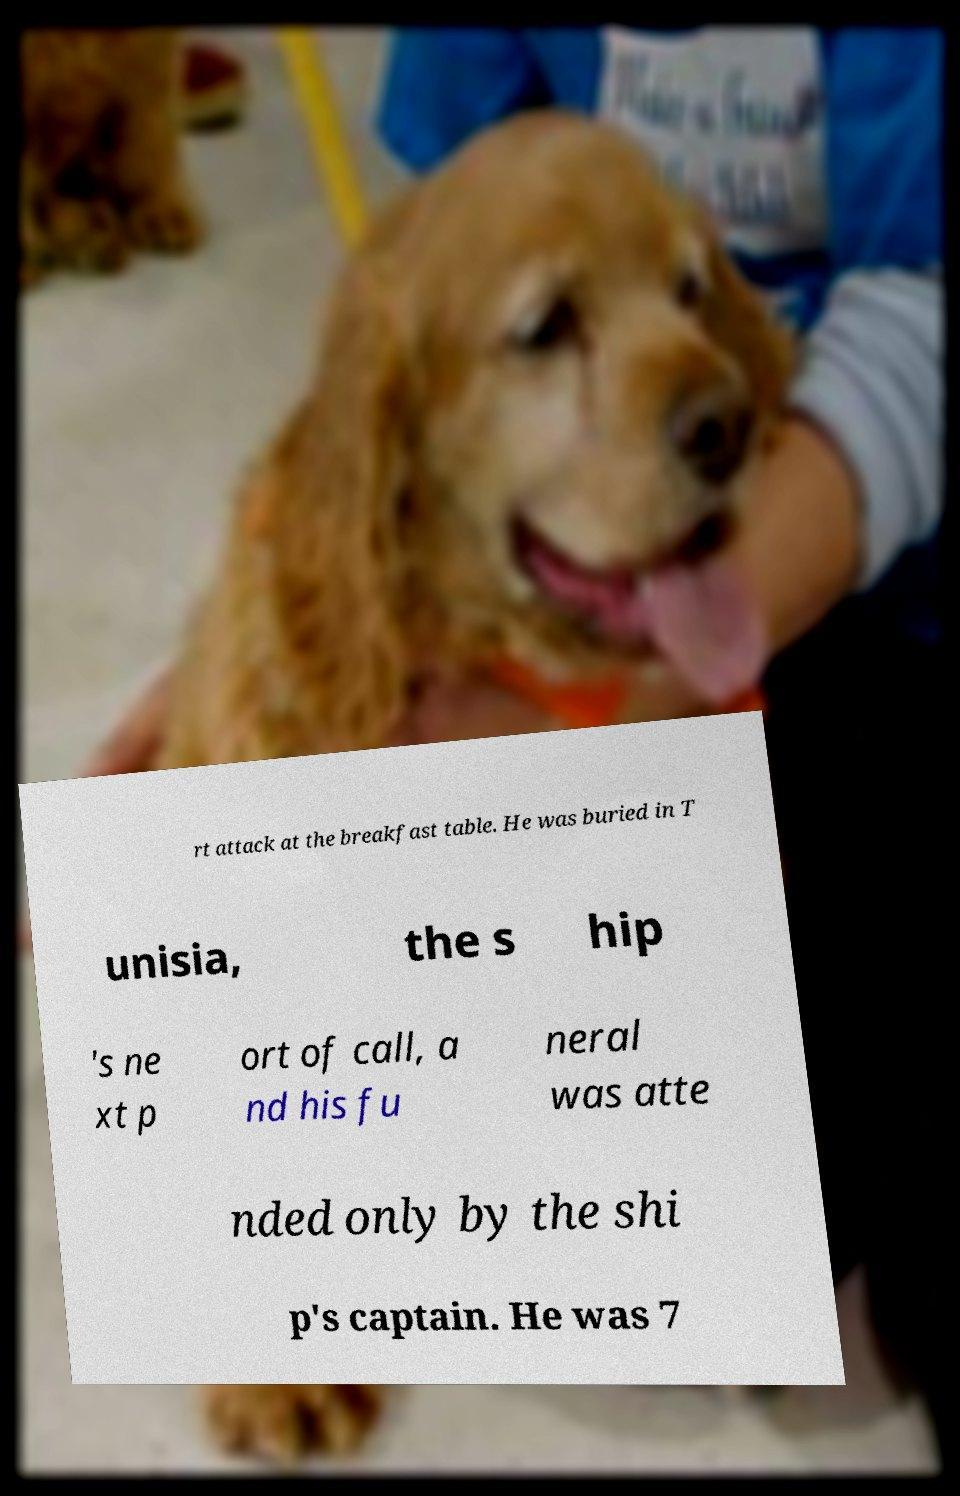Can you read and provide the text displayed in the image?This photo seems to have some interesting text. Can you extract and type it out for me? rt attack at the breakfast table. He was buried in T unisia, the s hip 's ne xt p ort of call, a nd his fu neral was atte nded only by the shi p's captain. He was 7 